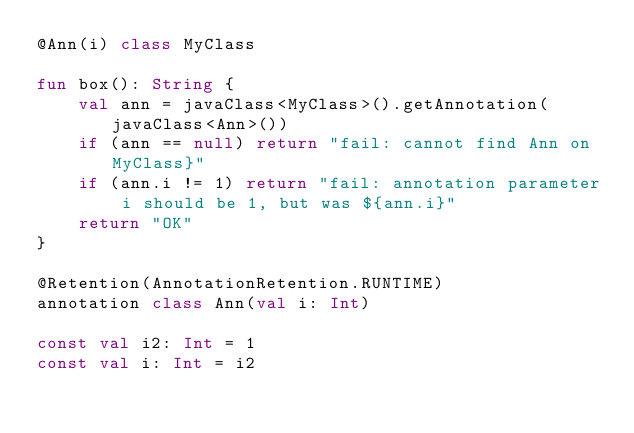<code> <loc_0><loc_0><loc_500><loc_500><_Kotlin_>@Ann(i) class MyClass

fun box(): String {
    val ann = javaClass<MyClass>().getAnnotation(javaClass<Ann>())
    if (ann == null) return "fail: cannot find Ann on MyClass}"
    if (ann.i != 1) return "fail: annotation parameter i should be 1, but was ${ann.i}"
    return "OK"
}

@Retention(AnnotationRetention.RUNTIME)
annotation class Ann(val i: Int)

const val i2: Int = 1
const val i: Int = i2
</code> 